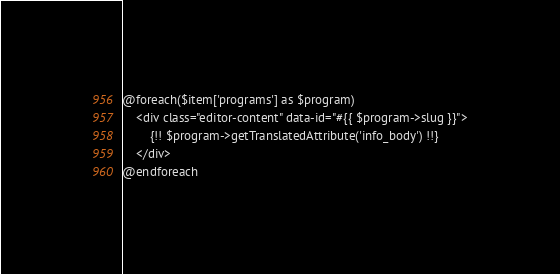<code> <loc_0><loc_0><loc_500><loc_500><_PHP_>
@foreach($item['programs'] as $program)
    <div class="editor-content" data-id="#{{ $program->slug }}">
        {!! $program->getTranslatedAttribute('info_body') !!}
    </div>
@endforeach
</code> 